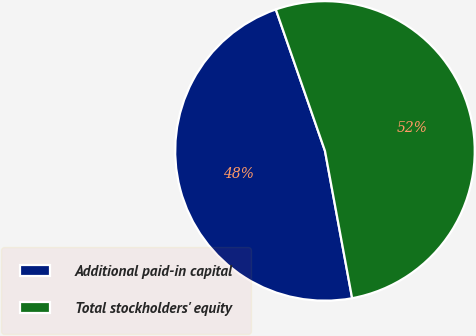<chart> <loc_0><loc_0><loc_500><loc_500><pie_chart><fcel>Additional paid-in capital<fcel>Total stockholders' equity<nl><fcel>47.58%<fcel>52.42%<nl></chart> 